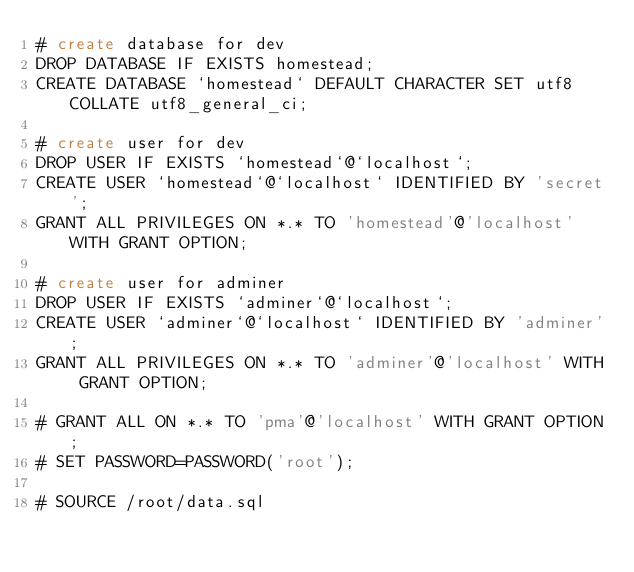Convert code to text. <code><loc_0><loc_0><loc_500><loc_500><_SQL_># create database for dev
DROP DATABASE IF EXISTS homestead;
CREATE DATABASE `homestead` DEFAULT CHARACTER SET utf8 COLLATE utf8_general_ci;

# create user for dev
DROP USER IF EXISTS `homestead`@`localhost`;
CREATE USER `homestead`@`localhost` IDENTIFIED BY 'secret';
GRANT ALL PRIVILEGES ON *.* TO 'homestead'@'localhost' WITH GRANT OPTION;

# create user for adminer
DROP USER IF EXISTS `adminer`@`localhost`;
CREATE USER `adminer`@`localhost` IDENTIFIED BY 'adminer';
GRANT ALL PRIVILEGES ON *.* TO 'adminer'@'localhost' WITH GRANT OPTION;

# GRANT ALL ON *.* TO 'pma'@'localhost' WITH GRANT OPTION;
# SET PASSWORD=PASSWORD('root');

# SOURCE /root/data.sql
</code> 